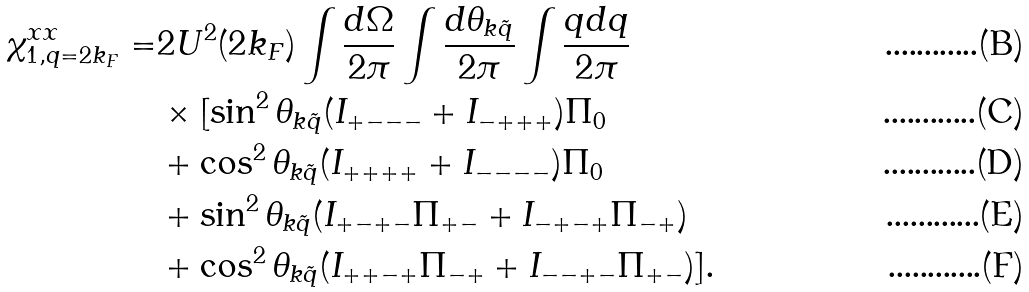Convert formula to latex. <formula><loc_0><loc_0><loc_500><loc_500>\chi _ { 1 , q = 2 k _ { F } } ^ { x x } = & 2 U ^ { 2 } ( 2 k _ { F } ) \int \frac { d \Omega } { 2 \pi } \int \frac { d \theta _ { k \tilde { q } } } { 2 \pi } \int \frac { q d q } { 2 \pi } \\ & \times [ \sin ^ { 2 } \theta _ { k \tilde { q } } ( I _ { + - - - } + I _ { - + + + } ) \Pi _ { 0 } \\ & + \cos ^ { 2 } \theta _ { k \tilde { q } } ( I _ { + + + + } + I _ { - - - - } ) \Pi _ { 0 } \\ & + \sin ^ { 2 } \theta _ { k \tilde { q } } ( I _ { + - + - } \Pi _ { + - } + I _ { - + - + } \Pi _ { - + } ) \\ & + \cos ^ { 2 } \theta _ { k \tilde { q } } ( I _ { + + - + } \Pi _ { - + } + I _ { - - + - } \Pi _ { + - } ) ] .</formula> 